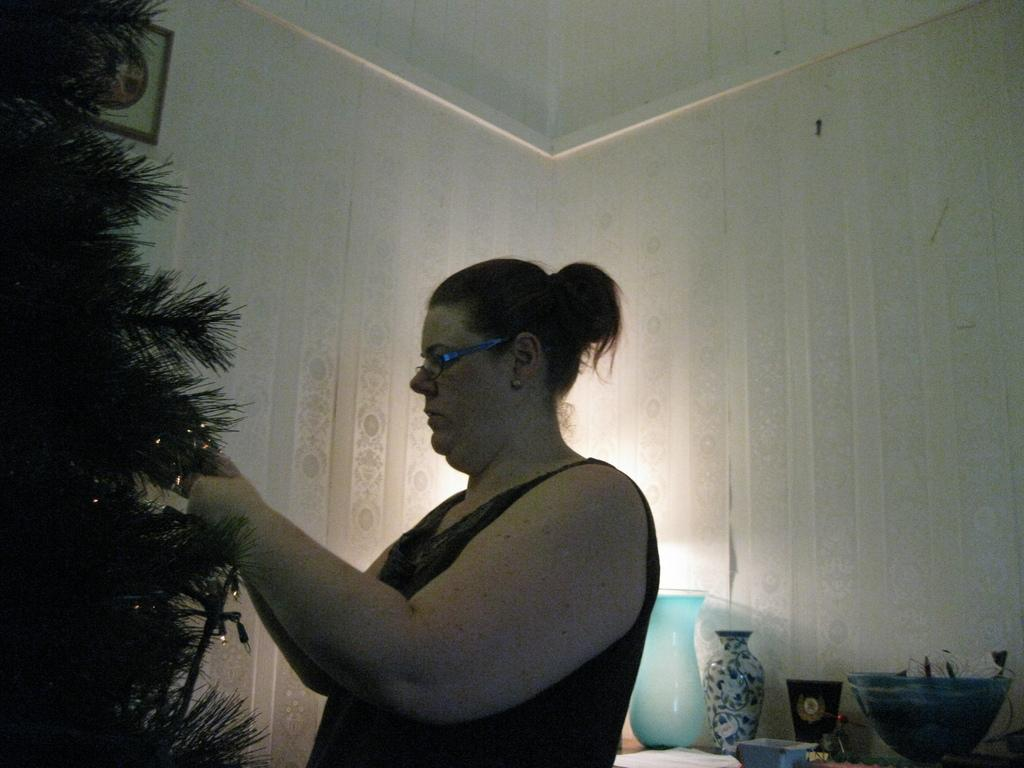Who is the main subject in the image? There is a lady in the image. What is the lady doing in the image? The lady is decorating a Christmas tree. What other objects can be seen on the table in the image? There is a vase, a jar, and a bowl on the table, along with other objects. Where is the photo frame located in the image? The photo frame is on the wall in the image. What type of lunch is being prepared in the image? There is no indication of lunch preparation in the image; the lady is decorating a Christmas tree. Can you see the moon in the image? The moon is not visible in the image; it is focused on the lady decorating the Christmas tree and the objects on the table and wall. 